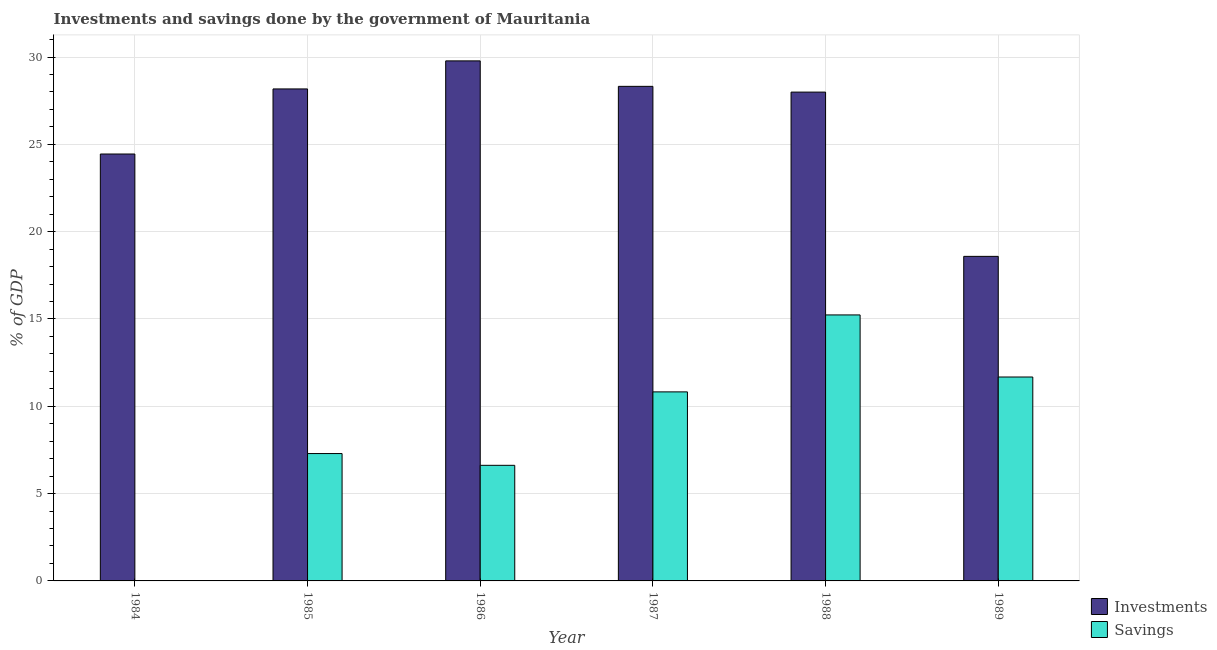Are the number of bars per tick equal to the number of legend labels?
Provide a succinct answer. No. Are the number of bars on each tick of the X-axis equal?
Provide a short and direct response. No. How many bars are there on the 5th tick from the right?
Give a very brief answer. 2. What is the label of the 5th group of bars from the left?
Offer a very short reply. 1988. What is the savings of government in 1985?
Make the answer very short. 7.29. Across all years, what is the maximum investments of government?
Provide a short and direct response. 29.78. Across all years, what is the minimum savings of government?
Your answer should be very brief. 0. What is the total investments of government in the graph?
Your answer should be very brief. 157.3. What is the difference between the savings of government in 1986 and that in 1987?
Your answer should be compact. -4.21. What is the difference between the investments of government in 1986 and the savings of government in 1985?
Make the answer very short. 1.61. What is the average savings of government per year?
Provide a short and direct response. 8.61. In how many years, is the investments of government greater than 11 %?
Provide a succinct answer. 6. What is the ratio of the investments of government in 1986 to that in 1989?
Keep it short and to the point. 1.6. What is the difference between the highest and the second highest investments of government?
Your response must be concise. 1.46. What is the difference between the highest and the lowest savings of government?
Make the answer very short. 15.23. Are the values on the major ticks of Y-axis written in scientific E-notation?
Your response must be concise. No. Does the graph contain any zero values?
Your answer should be very brief. Yes. Does the graph contain grids?
Offer a very short reply. Yes. How many legend labels are there?
Offer a terse response. 2. How are the legend labels stacked?
Provide a short and direct response. Vertical. What is the title of the graph?
Keep it short and to the point. Investments and savings done by the government of Mauritania. Does "Travel services" appear as one of the legend labels in the graph?
Keep it short and to the point. No. What is the label or title of the X-axis?
Provide a short and direct response. Year. What is the label or title of the Y-axis?
Your answer should be compact. % of GDP. What is the % of GDP in Investments in 1984?
Provide a short and direct response. 24.45. What is the % of GDP in Savings in 1984?
Keep it short and to the point. 0. What is the % of GDP in Investments in 1985?
Your answer should be very brief. 28.17. What is the % of GDP in Savings in 1985?
Your answer should be very brief. 7.29. What is the % of GDP of Investments in 1986?
Your response must be concise. 29.78. What is the % of GDP in Savings in 1986?
Keep it short and to the point. 6.62. What is the % of GDP in Investments in 1987?
Provide a succinct answer. 28.32. What is the % of GDP in Savings in 1987?
Provide a short and direct response. 10.83. What is the % of GDP of Investments in 1988?
Keep it short and to the point. 27.99. What is the % of GDP of Savings in 1988?
Provide a succinct answer. 15.23. What is the % of GDP in Investments in 1989?
Your answer should be very brief. 18.59. What is the % of GDP in Savings in 1989?
Ensure brevity in your answer.  11.68. Across all years, what is the maximum % of GDP of Investments?
Provide a short and direct response. 29.78. Across all years, what is the maximum % of GDP in Savings?
Your answer should be compact. 15.23. Across all years, what is the minimum % of GDP in Investments?
Offer a terse response. 18.59. What is the total % of GDP in Investments in the graph?
Offer a very short reply. 157.3. What is the total % of GDP of Savings in the graph?
Your answer should be compact. 51.65. What is the difference between the % of GDP in Investments in 1984 and that in 1985?
Offer a terse response. -3.73. What is the difference between the % of GDP in Investments in 1984 and that in 1986?
Provide a short and direct response. -5.33. What is the difference between the % of GDP in Investments in 1984 and that in 1987?
Give a very brief answer. -3.87. What is the difference between the % of GDP of Investments in 1984 and that in 1988?
Make the answer very short. -3.55. What is the difference between the % of GDP of Investments in 1984 and that in 1989?
Your answer should be very brief. 5.86. What is the difference between the % of GDP in Investments in 1985 and that in 1986?
Your answer should be very brief. -1.61. What is the difference between the % of GDP in Savings in 1985 and that in 1986?
Offer a very short reply. 0.67. What is the difference between the % of GDP in Investments in 1985 and that in 1987?
Make the answer very short. -0.15. What is the difference between the % of GDP of Savings in 1985 and that in 1987?
Your response must be concise. -3.53. What is the difference between the % of GDP of Investments in 1985 and that in 1988?
Your response must be concise. 0.18. What is the difference between the % of GDP in Savings in 1985 and that in 1988?
Your response must be concise. -7.94. What is the difference between the % of GDP in Investments in 1985 and that in 1989?
Provide a short and direct response. 9.59. What is the difference between the % of GDP of Savings in 1985 and that in 1989?
Make the answer very short. -4.38. What is the difference between the % of GDP of Investments in 1986 and that in 1987?
Ensure brevity in your answer.  1.46. What is the difference between the % of GDP of Savings in 1986 and that in 1987?
Your response must be concise. -4.21. What is the difference between the % of GDP in Investments in 1986 and that in 1988?
Make the answer very short. 1.79. What is the difference between the % of GDP of Savings in 1986 and that in 1988?
Give a very brief answer. -8.61. What is the difference between the % of GDP of Investments in 1986 and that in 1989?
Ensure brevity in your answer.  11.19. What is the difference between the % of GDP in Savings in 1986 and that in 1989?
Offer a terse response. -5.06. What is the difference between the % of GDP in Investments in 1987 and that in 1988?
Ensure brevity in your answer.  0.33. What is the difference between the % of GDP of Savings in 1987 and that in 1988?
Your answer should be compact. -4.41. What is the difference between the % of GDP in Investments in 1987 and that in 1989?
Your answer should be compact. 9.74. What is the difference between the % of GDP of Savings in 1987 and that in 1989?
Provide a short and direct response. -0.85. What is the difference between the % of GDP of Investments in 1988 and that in 1989?
Provide a succinct answer. 9.41. What is the difference between the % of GDP of Savings in 1988 and that in 1989?
Your answer should be compact. 3.55. What is the difference between the % of GDP in Investments in 1984 and the % of GDP in Savings in 1985?
Offer a terse response. 17.15. What is the difference between the % of GDP of Investments in 1984 and the % of GDP of Savings in 1986?
Give a very brief answer. 17.83. What is the difference between the % of GDP of Investments in 1984 and the % of GDP of Savings in 1987?
Provide a succinct answer. 13.62. What is the difference between the % of GDP of Investments in 1984 and the % of GDP of Savings in 1988?
Ensure brevity in your answer.  9.21. What is the difference between the % of GDP in Investments in 1984 and the % of GDP in Savings in 1989?
Offer a terse response. 12.77. What is the difference between the % of GDP of Investments in 1985 and the % of GDP of Savings in 1986?
Give a very brief answer. 21.55. What is the difference between the % of GDP of Investments in 1985 and the % of GDP of Savings in 1987?
Your answer should be compact. 17.35. What is the difference between the % of GDP in Investments in 1985 and the % of GDP in Savings in 1988?
Offer a terse response. 12.94. What is the difference between the % of GDP of Investments in 1985 and the % of GDP of Savings in 1989?
Offer a very short reply. 16.5. What is the difference between the % of GDP of Investments in 1986 and the % of GDP of Savings in 1987?
Your answer should be very brief. 18.95. What is the difference between the % of GDP of Investments in 1986 and the % of GDP of Savings in 1988?
Your answer should be very brief. 14.55. What is the difference between the % of GDP in Investments in 1986 and the % of GDP in Savings in 1989?
Offer a very short reply. 18.1. What is the difference between the % of GDP in Investments in 1987 and the % of GDP in Savings in 1988?
Provide a succinct answer. 13.09. What is the difference between the % of GDP in Investments in 1987 and the % of GDP in Savings in 1989?
Provide a succinct answer. 16.64. What is the difference between the % of GDP of Investments in 1988 and the % of GDP of Savings in 1989?
Your answer should be very brief. 16.31. What is the average % of GDP of Investments per year?
Offer a terse response. 26.22. What is the average % of GDP of Savings per year?
Offer a terse response. 8.61. In the year 1985, what is the difference between the % of GDP in Investments and % of GDP in Savings?
Keep it short and to the point. 20.88. In the year 1986, what is the difference between the % of GDP of Investments and % of GDP of Savings?
Give a very brief answer. 23.16. In the year 1987, what is the difference between the % of GDP of Investments and % of GDP of Savings?
Your answer should be compact. 17.5. In the year 1988, what is the difference between the % of GDP in Investments and % of GDP in Savings?
Provide a succinct answer. 12.76. In the year 1989, what is the difference between the % of GDP of Investments and % of GDP of Savings?
Your answer should be compact. 6.91. What is the ratio of the % of GDP of Investments in 1984 to that in 1985?
Provide a succinct answer. 0.87. What is the ratio of the % of GDP of Investments in 1984 to that in 1986?
Offer a very short reply. 0.82. What is the ratio of the % of GDP of Investments in 1984 to that in 1987?
Provide a succinct answer. 0.86. What is the ratio of the % of GDP of Investments in 1984 to that in 1988?
Your answer should be very brief. 0.87. What is the ratio of the % of GDP of Investments in 1984 to that in 1989?
Your response must be concise. 1.32. What is the ratio of the % of GDP of Investments in 1985 to that in 1986?
Offer a very short reply. 0.95. What is the ratio of the % of GDP of Savings in 1985 to that in 1986?
Your answer should be very brief. 1.1. What is the ratio of the % of GDP in Investments in 1985 to that in 1987?
Your response must be concise. 0.99. What is the ratio of the % of GDP of Savings in 1985 to that in 1987?
Your answer should be compact. 0.67. What is the ratio of the % of GDP in Savings in 1985 to that in 1988?
Provide a short and direct response. 0.48. What is the ratio of the % of GDP of Investments in 1985 to that in 1989?
Your answer should be very brief. 1.52. What is the ratio of the % of GDP in Savings in 1985 to that in 1989?
Make the answer very short. 0.62. What is the ratio of the % of GDP of Investments in 1986 to that in 1987?
Provide a short and direct response. 1.05. What is the ratio of the % of GDP of Savings in 1986 to that in 1987?
Make the answer very short. 0.61. What is the ratio of the % of GDP of Investments in 1986 to that in 1988?
Offer a terse response. 1.06. What is the ratio of the % of GDP of Savings in 1986 to that in 1988?
Your response must be concise. 0.43. What is the ratio of the % of GDP in Investments in 1986 to that in 1989?
Your answer should be very brief. 1.6. What is the ratio of the % of GDP of Savings in 1986 to that in 1989?
Provide a succinct answer. 0.57. What is the ratio of the % of GDP of Investments in 1987 to that in 1988?
Your response must be concise. 1.01. What is the ratio of the % of GDP in Savings in 1987 to that in 1988?
Your response must be concise. 0.71. What is the ratio of the % of GDP of Investments in 1987 to that in 1989?
Ensure brevity in your answer.  1.52. What is the ratio of the % of GDP of Savings in 1987 to that in 1989?
Give a very brief answer. 0.93. What is the ratio of the % of GDP of Investments in 1988 to that in 1989?
Give a very brief answer. 1.51. What is the ratio of the % of GDP of Savings in 1988 to that in 1989?
Provide a succinct answer. 1.3. What is the difference between the highest and the second highest % of GDP in Investments?
Provide a short and direct response. 1.46. What is the difference between the highest and the second highest % of GDP in Savings?
Give a very brief answer. 3.55. What is the difference between the highest and the lowest % of GDP in Investments?
Provide a short and direct response. 11.19. What is the difference between the highest and the lowest % of GDP in Savings?
Provide a succinct answer. 15.23. 